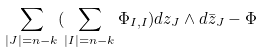Convert formula to latex. <formula><loc_0><loc_0><loc_500><loc_500>\sum _ { | J | = n - k } ( \sum _ { | I | = n - k } \Phi _ { I , I } ) d z _ { J } \wedge d \bar { z } _ { J } - \Phi</formula> 